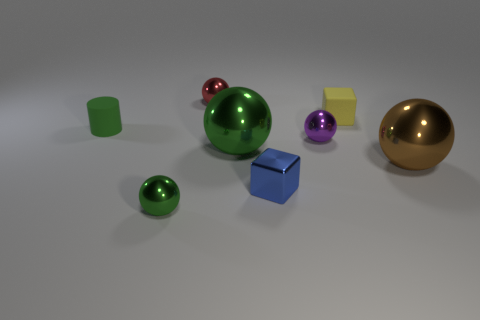Subtract 1 spheres. How many spheres are left? 4 Subtract all big green balls. How many balls are left? 4 Subtract all purple balls. How many balls are left? 4 Subtract all gray spheres. Subtract all gray cubes. How many spheres are left? 5 Add 2 red matte cylinders. How many objects exist? 10 Subtract all cylinders. How many objects are left? 7 Subtract 0 gray cylinders. How many objects are left? 8 Subtract all cylinders. Subtract all small blue metallic blocks. How many objects are left? 6 Add 8 small green rubber objects. How many small green rubber objects are left? 9 Add 6 large brown metallic cylinders. How many large brown metallic cylinders exist? 6 